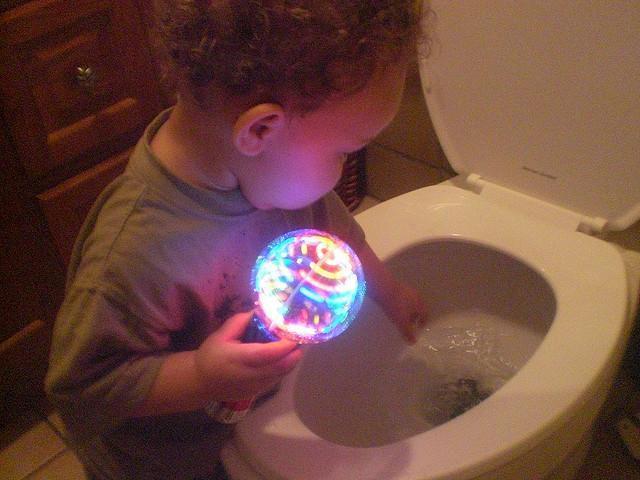How many toilets can you see?
Give a very brief answer. 1. 